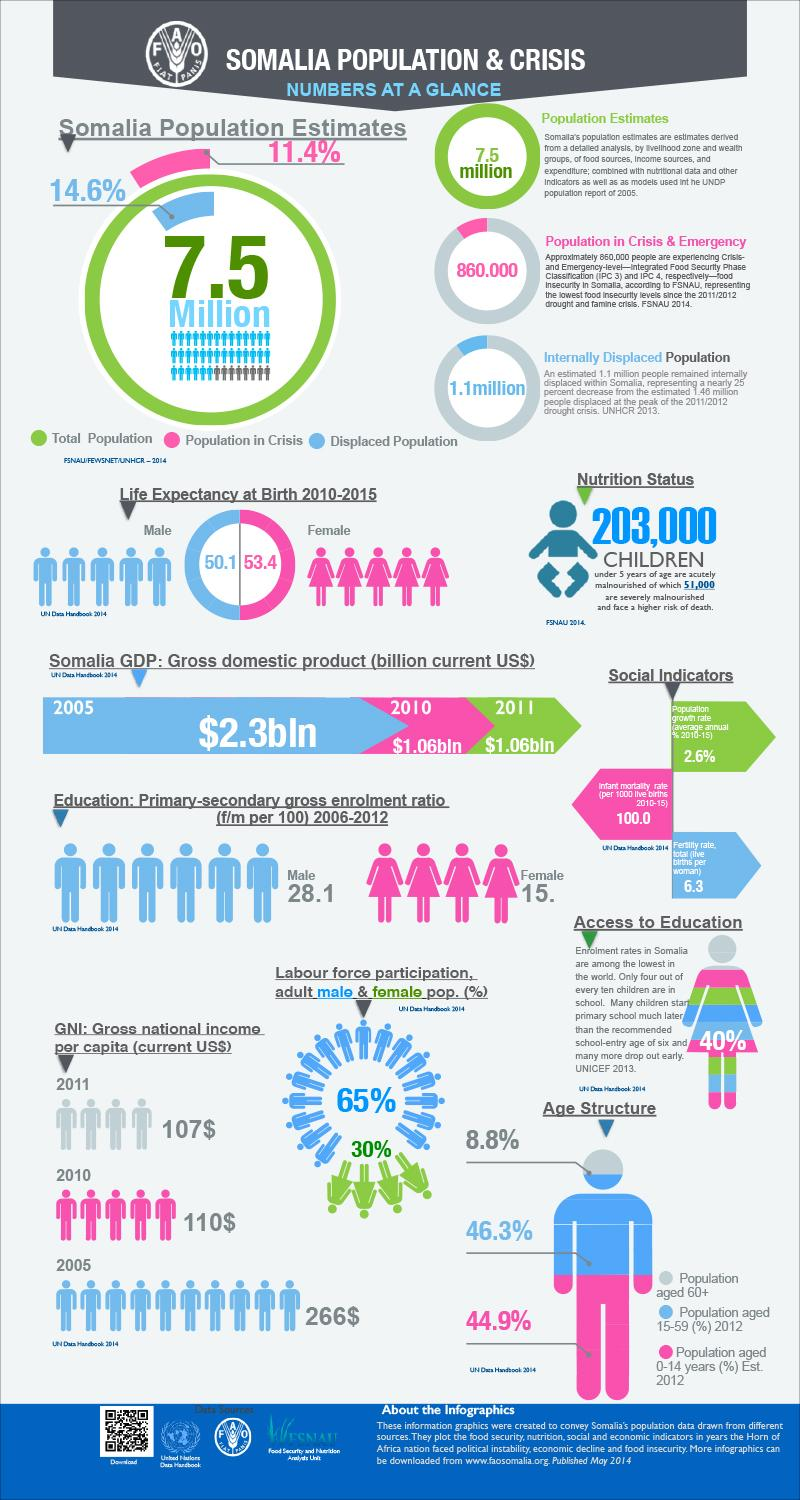List a handful of essential elements in this visual. In the age groups of 60 and over and 0 to 14, taken together, 53.7% of the population is represented. The population can be divided into two age groups: those aged 60 and above, and those aged 15 to 59. The combined percentage of these two age groups is 55.1%. In Somalia, approximately 40% of the enrollment is female. 